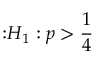<formula> <loc_0><loc_0><loc_500><loc_500>{ \colon } H _ { 1 } \colon p > { \frac { 1 } { 4 } }</formula> 